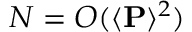Convert formula to latex. <formula><loc_0><loc_0><loc_500><loc_500>N = O ( \langle P \rangle ^ { 2 } )</formula> 